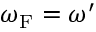<formula> <loc_0><loc_0><loc_500><loc_500>\omega _ { F } = \omega ^ { \prime }</formula> 